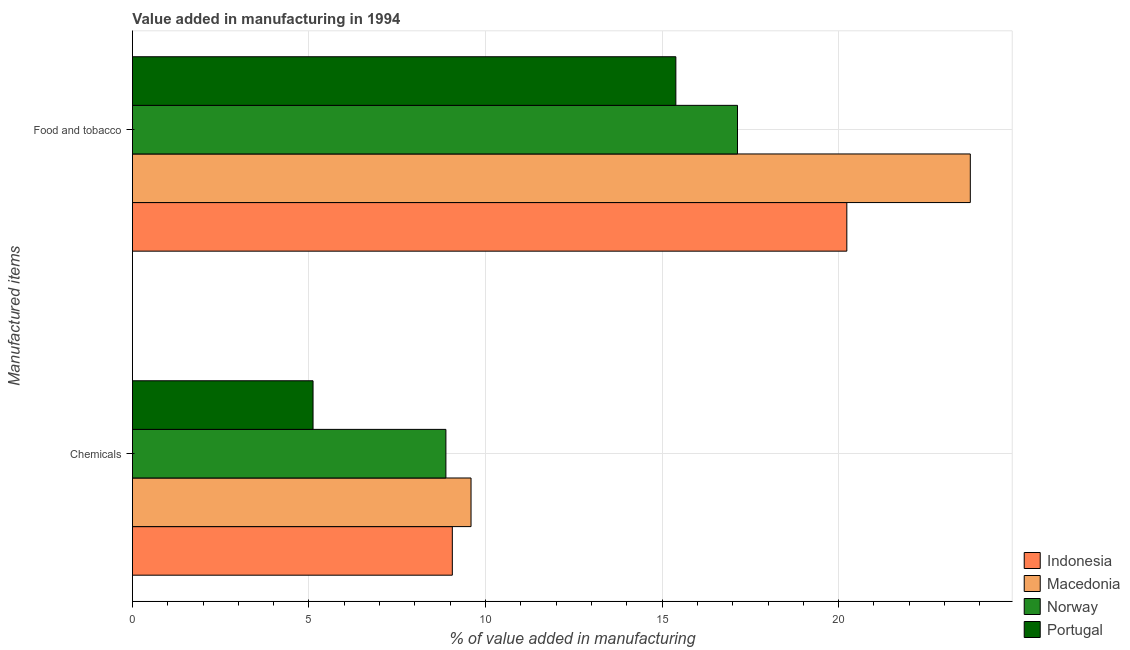Are the number of bars on each tick of the Y-axis equal?
Give a very brief answer. Yes. How many bars are there on the 2nd tick from the top?
Your answer should be very brief. 4. What is the label of the 1st group of bars from the top?
Your response must be concise. Food and tobacco. What is the value added by manufacturing food and tobacco in Norway?
Provide a short and direct response. 17.14. Across all countries, what is the maximum value added by manufacturing food and tobacco?
Make the answer very short. 23.73. Across all countries, what is the minimum value added by manufacturing food and tobacco?
Provide a short and direct response. 15.39. In which country was the value added by  manufacturing chemicals maximum?
Provide a short and direct response. Macedonia. What is the total value added by manufacturing food and tobacco in the graph?
Give a very brief answer. 76.49. What is the difference between the value added by manufacturing food and tobacco in Portugal and that in Macedonia?
Offer a very short reply. -8.34. What is the difference between the value added by  manufacturing chemicals in Macedonia and the value added by manufacturing food and tobacco in Portugal?
Provide a short and direct response. -5.8. What is the average value added by manufacturing food and tobacco per country?
Ensure brevity in your answer.  19.12. What is the difference between the value added by  manufacturing chemicals and value added by manufacturing food and tobacco in Portugal?
Give a very brief answer. -10.28. In how many countries, is the value added by manufacturing food and tobacco greater than 23 %?
Ensure brevity in your answer.  1. What is the ratio of the value added by manufacturing food and tobacco in Indonesia to that in Macedonia?
Keep it short and to the point. 0.85. Is the value added by  manufacturing chemicals in Indonesia less than that in Macedonia?
Ensure brevity in your answer.  Yes. In how many countries, is the value added by manufacturing food and tobacco greater than the average value added by manufacturing food and tobacco taken over all countries?
Your answer should be very brief. 2. What does the 2nd bar from the top in Food and tobacco represents?
Provide a short and direct response. Norway. Are all the bars in the graph horizontal?
Your answer should be compact. Yes. What is the difference between two consecutive major ticks on the X-axis?
Your response must be concise. 5. Does the graph contain grids?
Offer a terse response. Yes. How many legend labels are there?
Your response must be concise. 4. What is the title of the graph?
Your answer should be very brief. Value added in manufacturing in 1994. Does "Sudan" appear as one of the legend labels in the graph?
Your answer should be compact. No. What is the label or title of the X-axis?
Offer a very short reply. % of value added in manufacturing. What is the label or title of the Y-axis?
Your answer should be very brief. Manufactured items. What is the % of value added in manufacturing in Indonesia in Chemicals?
Provide a short and direct response. 9.06. What is the % of value added in manufacturing of Macedonia in Chemicals?
Offer a very short reply. 9.59. What is the % of value added in manufacturing in Norway in Chemicals?
Your answer should be compact. 8.88. What is the % of value added in manufacturing of Portugal in Chemicals?
Your answer should be compact. 5.11. What is the % of value added in manufacturing of Indonesia in Food and tobacco?
Make the answer very short. 20.23. What is the % of value added in manufacturing of Macedonia in Food and tobacco?
Provide a short and direct response. 23.73. What is the % of value added in manufacturing in Norway in Food and tobacco?
Offer a very short reply. 17.14. What is the % of value added in manufacturing of Portugal in Food and tobacco?
Provide a short and direct response. 15.39. Across all Manufactured items, what is the maximum % of value added in manufacturing of Indonesia?
Offer a very short reply. 20.23. Across all Manufactured items, what is the maximum % of value added in manufacturing in Macedonia?
Make the answer very short. 23.73. Across all Manufactured items, what is the maximum % of value added in manufacturing of Norway?
Keep it short and to the point. 17.14. Across all Manufactured items, what is the maximum % of value added in manufacturing of Portugal?
Give a very brief answer. 15.39. Across all Manufactured items, what is the minimum % of value added in manufacturing of Indonesia?
Offer a very short reply. 9.06. Across all Manufactured items, what is the minimum % of value added in manufacturing of Macedonia?
Offer a very short reply. 9.59. Across all Manufactured items, what is the minimum % of value added in manufacturing in Norway?
Provide a short and direct response. 8.88. Across all Manufactured items, what is the minimum % of value added in manufacturing in Portugal?
Provide a short and direct response. 5.11. What is the total % of value added in manufacturing in Indonesia in the graph?
Your response must be concise. 29.29. What is the total % of value added in manufacturing in Macedonia in the graph?
Make the answer very short. 33.32. What is the total % of value added in manufacturing in Norway in the graph?
Keep it short and to the point. 26.01. What is the total % of value added in manufacturing of Portugal in the graph?
Provide a short and direct response. 20.51. What is the difference between the % of value added in manufacturing in Indonesia in Chemicals and that in Food and tobacco?
Your answer should be very brief. -11.17. What is the difference between the % of value added in manufacturing in Macedonia in Chemicals and that in Food and tobacco?
Offer a terse response. -14.14. What is the difference between the % of value added in manufacturing in Norway in Chemicals and that in Food and tobacco?
Provide a succinct answer. -8.26. What is the difference between the % of value added in manufacturing in Portugal in Chemicals and that in Food and tobacco?
Provide a short and direct response. -10.28. What is the difference between the % of value added in manufacturing of Indonesia in Chemicals and the % of value added in manufacturing of Macedonia in Food and tobacco?
Your answer should be very brief. -14.67. What is the difference between the % of value added in manufacturing of Indonesia in Chemicals and the % of value added in manufacturing of Norway in Food and tobacco?
Offer a very short reply. -8.08. What is the difference between the % of value added in manufacturing of Indonesia in Chemicals and the % of value added in manufacturing of Portugal in Food and tobacco?
Give a very brief answer. -6.33. What is the difference between the % of value added in manufacturing of Macedonia in Chemicals and the % of value added in manufacturing of Norway in Food and tobacco?
Your answer should be very brief. -7.55. What is the difference between the % of value added in manufacturing in Macedonia in Chemicals and the % of value added in manufacturing in Portugal in Food and tobacco?
Ensure brevity in your answer.  -5.8. What is the difference between the % of value added in manufacturing in Norway in Chemicals and the % of value added in manufacturing in Portugal in Food and tobacco?
Your answer should be compact. -6.51. What is the average % of value added in manufacturing in Indonesia per Manufactured items?
Your response must be concise. 14.65. What is the average % of value added in manufacturing in Macedonia per Manufactured items?
Your answer should be very brief. 16.66. What is the average % of value added in manufacturing in Norway per Manufactured items?
Offer a very short reply. 13.01. What is the average % of value added in manufacturing of Portugal per Manufactured items?
Your response must be concise. 10.25. What is the difference between the % of value added in manufacturing in Indonesia and % of value added in manufacturing in Macedonia in Chemicals?
Make the answer very short. -0.53. What is the difference between the % of value added in manufacturing of Indonesia and % of value added in manufacturing of Norway in Chemicals?
Make the answer very short. 0.18. What is the difference between the % of value added in manufacturing of Indonesia and % of value added in manufacturing of Portugal in Chemicals?
Make the answer very short. 3.94. What is the difference between the % of value added in manufacturing of Macedonia and % of value added in manufacturing of Norway in Chemicals?
Ensure brevity in your answer.  0.71. What is the difference between the % of value added in manufacturing of Macedonia and % of value added in manufacturing of Portugal in Chemicals?
Make the answer very short. 4.47. What is the difference between the % of value added in manufacturing in Norway and % of value added in manufacturing in Portugal in Chemicals?
Provide a succinct answer. 3.76. What is the difference between the % of value added in manufacturing of Indonesia and % of value added in manufacturing of Macedonia in Food and tobacco?
Provide a short and direct response. -3.5. What is the difference between the % of value added in manufacturing in Indonesia and % of value added in manufacturing in Norway in Food and tobacco?
Offer a very short reply. 3.1. What is the difference between the % of value added in manufacturing in Indonesia and % of value added in manufacturing in Portugal in Food and tobacco?
Your response must be concise. 4.84. What is the difference between the % of value added in manufacturing of Macedonia and % of value added in manufacturing of Norway in Food and tobacco?
Your response must be concise. 6.59. What is the difference between the % of value added in manufacturing of Macedonia and % of value added in manufacturing of Portugal in Food and tobacco?
Provide a short and direct response. 8.34. What is the difference between the % of value added in manufacturing in Norway and % of value added in manufacturing in Portugal in Food and tobacco?
Your response must be concise. 1.75. What is the ratio of the % of value added in manufacturing in Indonesia in Chemicals to that in Food and tobacco?
Offer a very short reply. 0.45. What is the ratio of the % of value added in manufacturing of Macedonia in Chemicals to that in Food and tobacco?
Your answer should be compact. 0.4. What is the ratio of the % of value added in manufacturing in Norway in Chemicals to that in Food and tobacco?
Your answer should be very brief. 0.52. What is the ratio of the % of value added in manufacturing in Portugal in Chemicals to that in Food and tobacco?
Offer a very short reply. 0.33. What is the difference between the highest and the second highest % of value added in manufacturing in Indonesia?
Your answer should be compact. 11.17. What is the difference between the highest and the second highest % of value added in manufacturing in Macedonia?
Offer a very short reply. 14.14. What is the difference between the highest and the second highest % of value added in manufacturing of Norway?
Offer a very short reply. 8.26. What is the difference between the highest and the second highest % of value added in manufacturing in Portugal?
Make the answer very short. 10.28. What is the difference between the highest and the lowest % of value added in manufacturing in Indonesia?
Your answer should be very brief. 11.17. What is the difference between the highest and the lowest % of value added in manufacturing of Macedonia?
Your answer should be compact. 14.14. What is the difference between the highest and the lowest % of value added in manufacturing of Norway?
Your answer should be very brief. 8.26. What is the difference between the highest and the lowest % of value added in manufacturing of Portugal?
Ensure brevity in your answer.  10.28. 